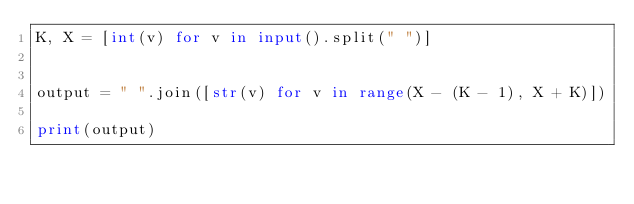<code> <loc_0><loc_0><loc_500><loc_500><_Python_>K, X = [int(v) for v in input().split(" ")]


output = " ".join([str(v) for v in range(X - (K - 1), X + K)])

print(output)</code> 